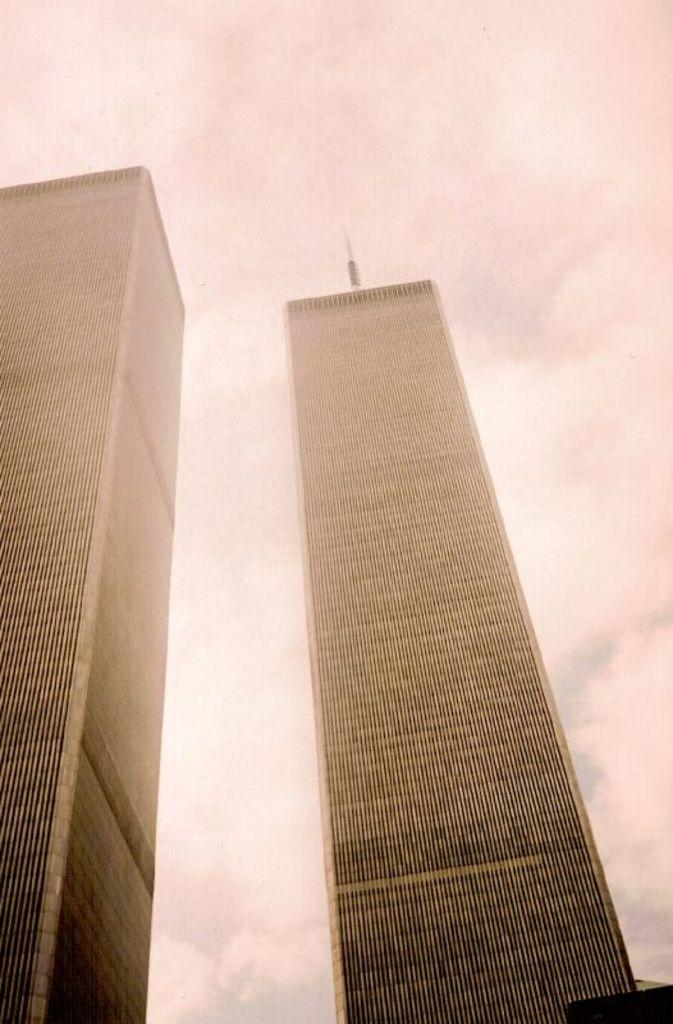What can be seen in the foreground of the image? There are two buildings in the foreground of the image. What is visible in the background of the image? There are clouds and the sky visible in the background of the image. What flavor of ice cream is being sold at the store in the image? There is no store or ice cream present in the image; it features two buildings and a sky with clouds. 